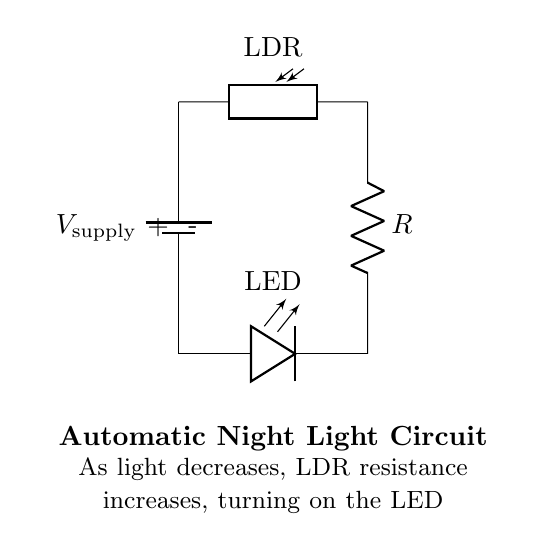What components are in this circuit? The components in the circuit are a battery, a photoresistor, a resistor, and an LED. Each of these components is clearly labeled in the circuit diagram.
Answer: battery, photoresistor, resistor, LED What does the LDR stand for? LDR stands for Light Dependent Resistor, which is the component that changes its resistance based on light intensity. This is indicated by the label next to the photoresistor in the diagram.
Answer: Light Dependent Resistor How does light affect the LDR? As light decreases, the resistance of the LDR increases, which is a fundamental property of photoresistors. This effect is stated in the explanation below the circuit diagram.
Answer: Resistance increases What is the function of the resistor in this circuit? The resistor helps control the current flowing through the LED to prevent it from burning out by limiting the voltage drop across the LED. This can be inferred from standard circuit practices, although it is not explicitly labeled in the diagram.
Answer: Current limiting What happens when the light level is low? When the light level is low, the LDR's resistance increases, causing the current to flow through the circuit, which turns on the LED. This is explained in the circuit description.
Answer: LED turns on What type of circuit is this? This circuit is a simple automatic night light circuit designed to turn on an LED automatically when ambient light conditions drop below a certain level. The components and their configuration indicate this specific use.
Answer: Automatic night light circuit What is the voltage supply used in this circuit? The circuit shows a battery as the power source, but it specifically does not indicate the voltage value. Assuming typical values for similar circuits, we can often see 5V as a common supply voltage, but it is not explicitly stated here.
Answer: V supply (assumed) 